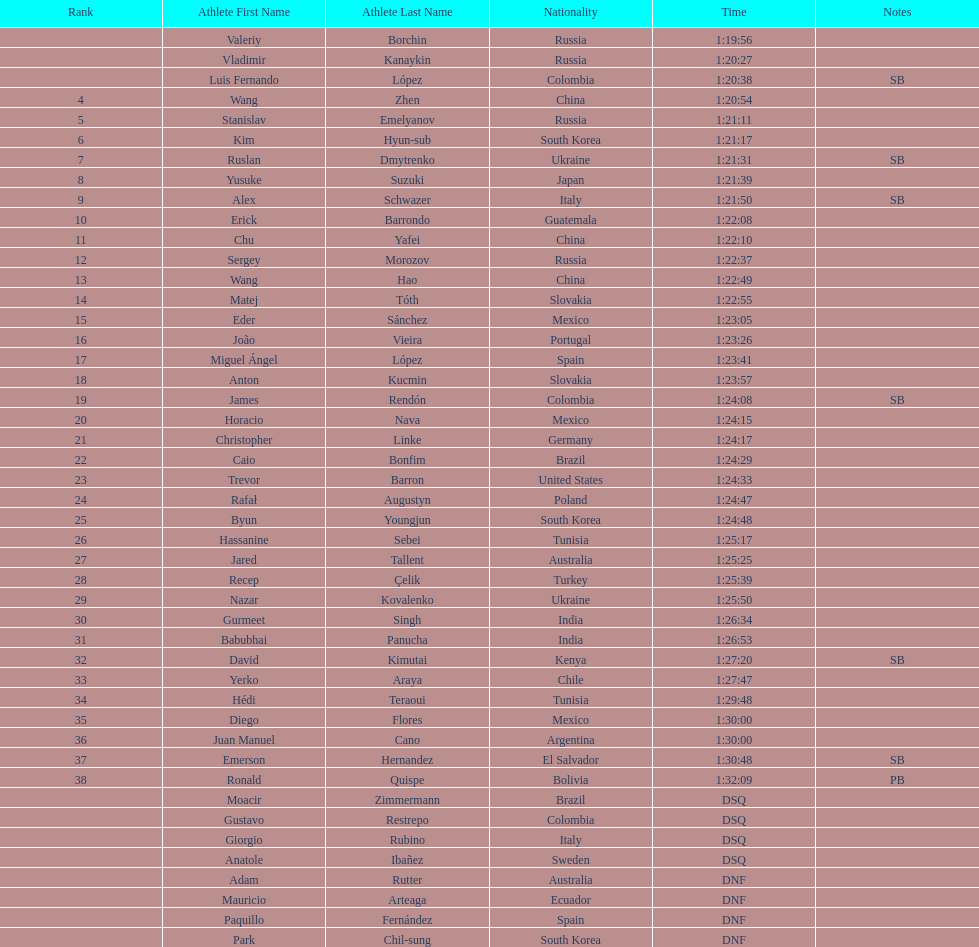How many russians finished at least 3rd in the 20km walk? 2. 